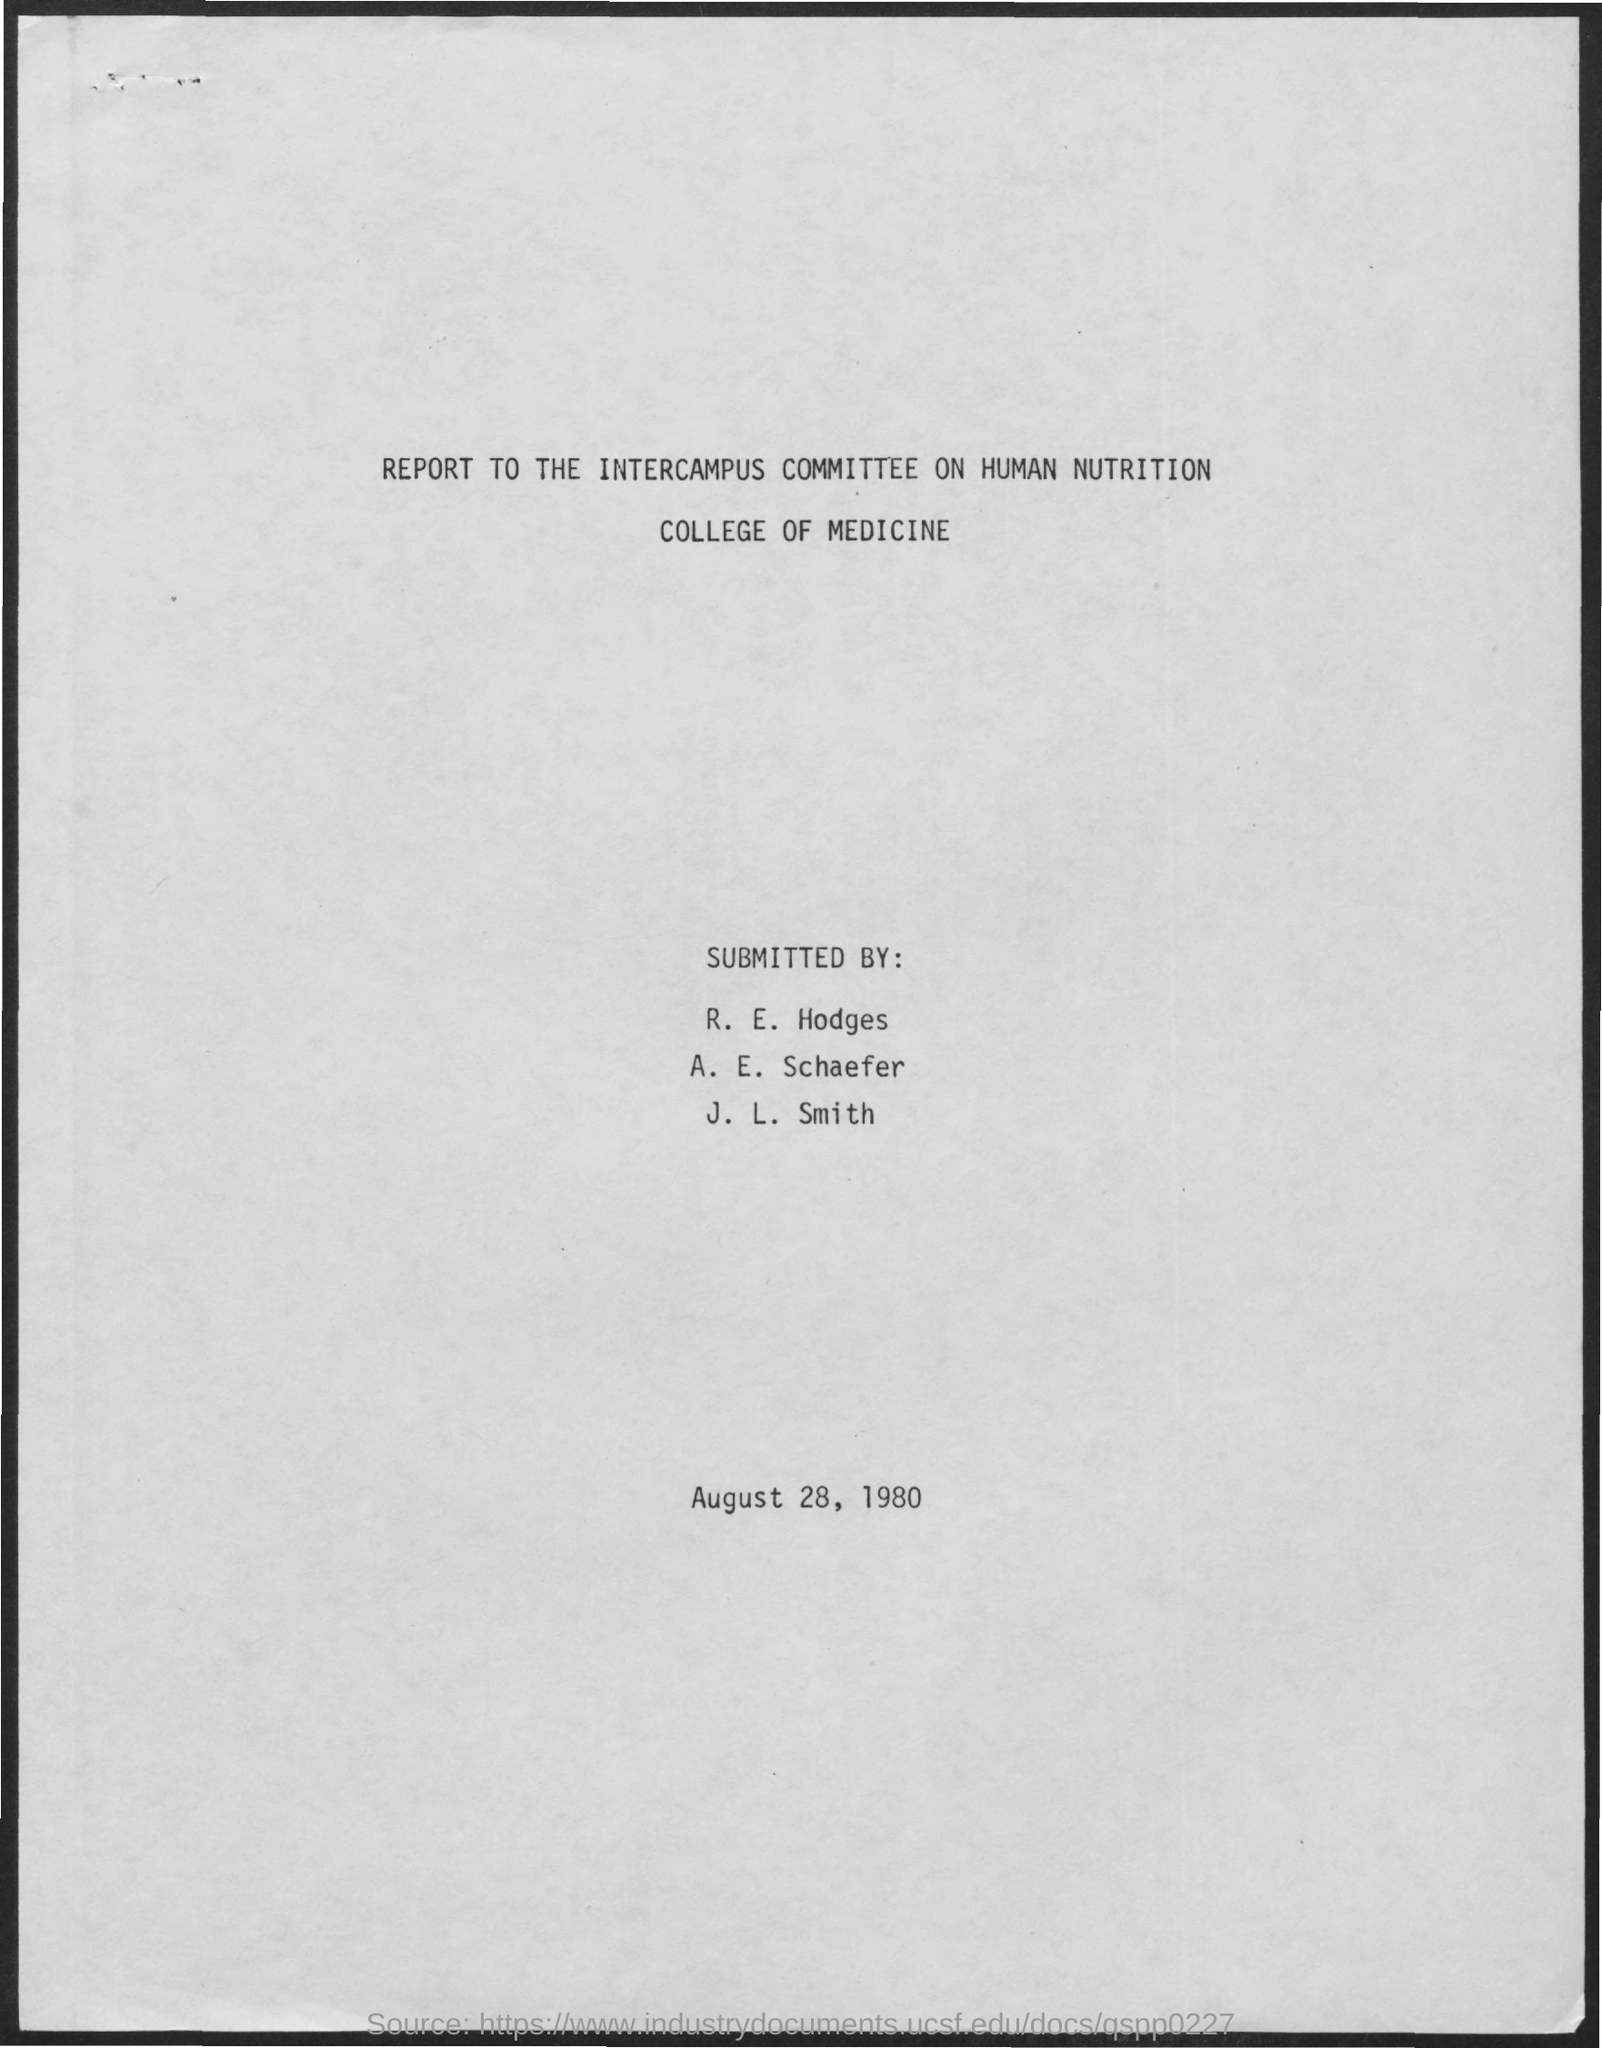What is the report on?
Your answer should be compact. Human nutrition. The report is to whom?
Ensure brevity in your answer.  The intercampus committee. Which college is it?
Give a very brief answer. College of medicine. The report is submitted on which date?
Provide a succinct answer. August 28, 1980. 